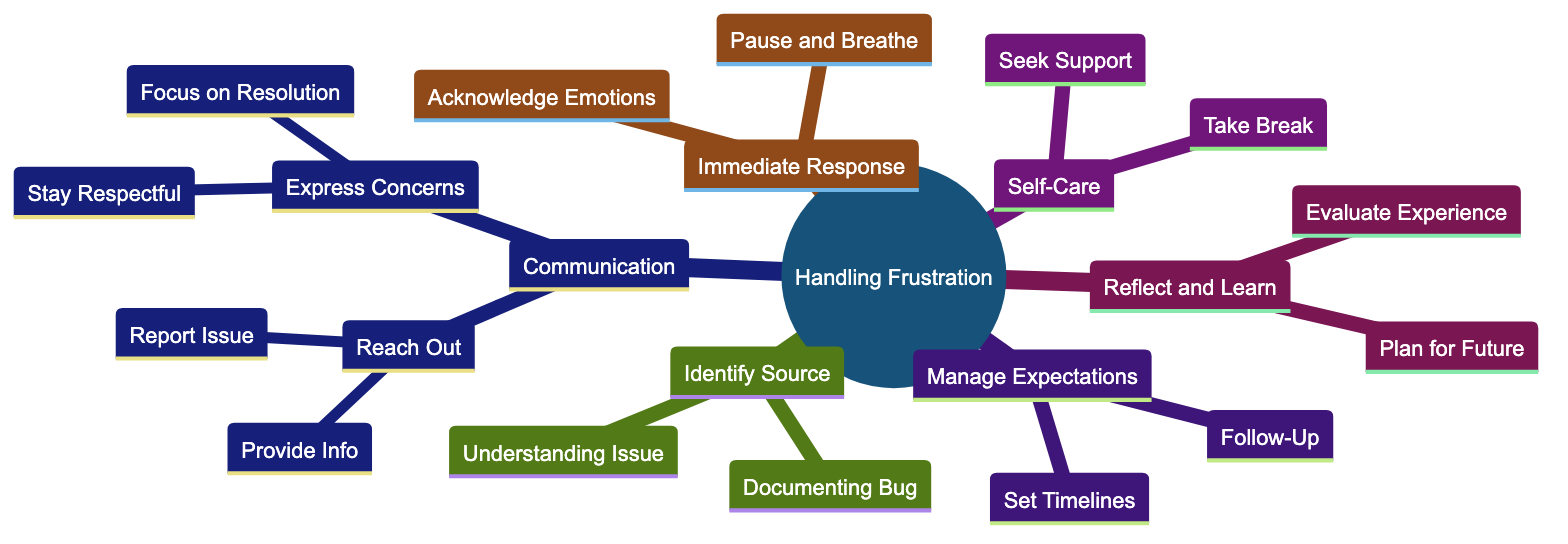What is the main topic of the mind map? The central theme of the mind map, which is stated in the root node, is related to handling frustration as a customer.
Answer: Handling Frustration How many main categories are present in the diagram? The diagram consists of six main categories branching from the root node, which are divided into distinct emotional and psychological steps.
Answer: Six What does "Pause and Breathe" fall under? "Pause and Breathe" is categorized under "Immediate Response," indicating an initial step in managing frustration.
Answer: Immediate Response Which category contains the action "Seek Support"? "Seek Support" is part of the "Self-Care" category, representing a personal strategy to cope with frustration.
Answer: Self-Care What is the relationship between “Report the Issue” and “Provide Necessary Information”? Both "Report the Issue" and "Provide Necessary Information" are sub-nodes under the same parent node "Reach Out to Support," illustrating steps to effectively communicate with customer support.
Answer: Reach Out to Support What advice is given regarding communication with support teams? The diagram suggests expressing concerns constructively while remaining respectful and focusing on resolution, emphasizing the importance of effective communication.
Answer: Express Concerns Constructively What should customers do if they don't receive a response in a reasonable time? The diagram advises to politely follow up if there has been no response after a reasonable period, shown under "Manage Expectations."
Answer: Follow-Up What is the last step discussed in the diagram? The last step in the mind map is "Plan for Future," indicating a reflective approach toward preventing similar frustrations in the future.
Answer: Plan for Future What is a recommended self-care activity? One recommended self-care activity mentioned in the diagram is "Take Break," suggesting a method for customers to manage their emotional state.
Answer: Take Break 